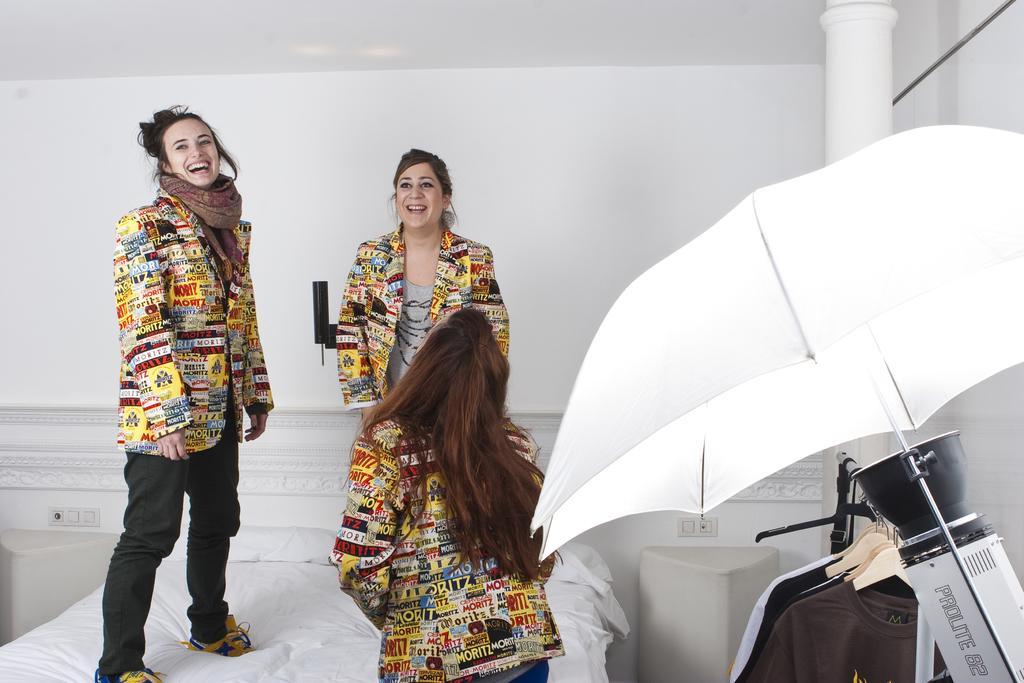Could you give a brief overview of what you see in this image? In this image, we can see people wearing clothes. There is a port umbrella on the right side of the image. There is a pillar in front of the wall. There is a bed at the bottom of the image. There are clothes in the bottom right of the image. 